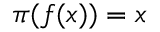<formula> <loc_0><loc_0><loc_500><loc_500>\pi ( f ( x ) ) = x</formula> 